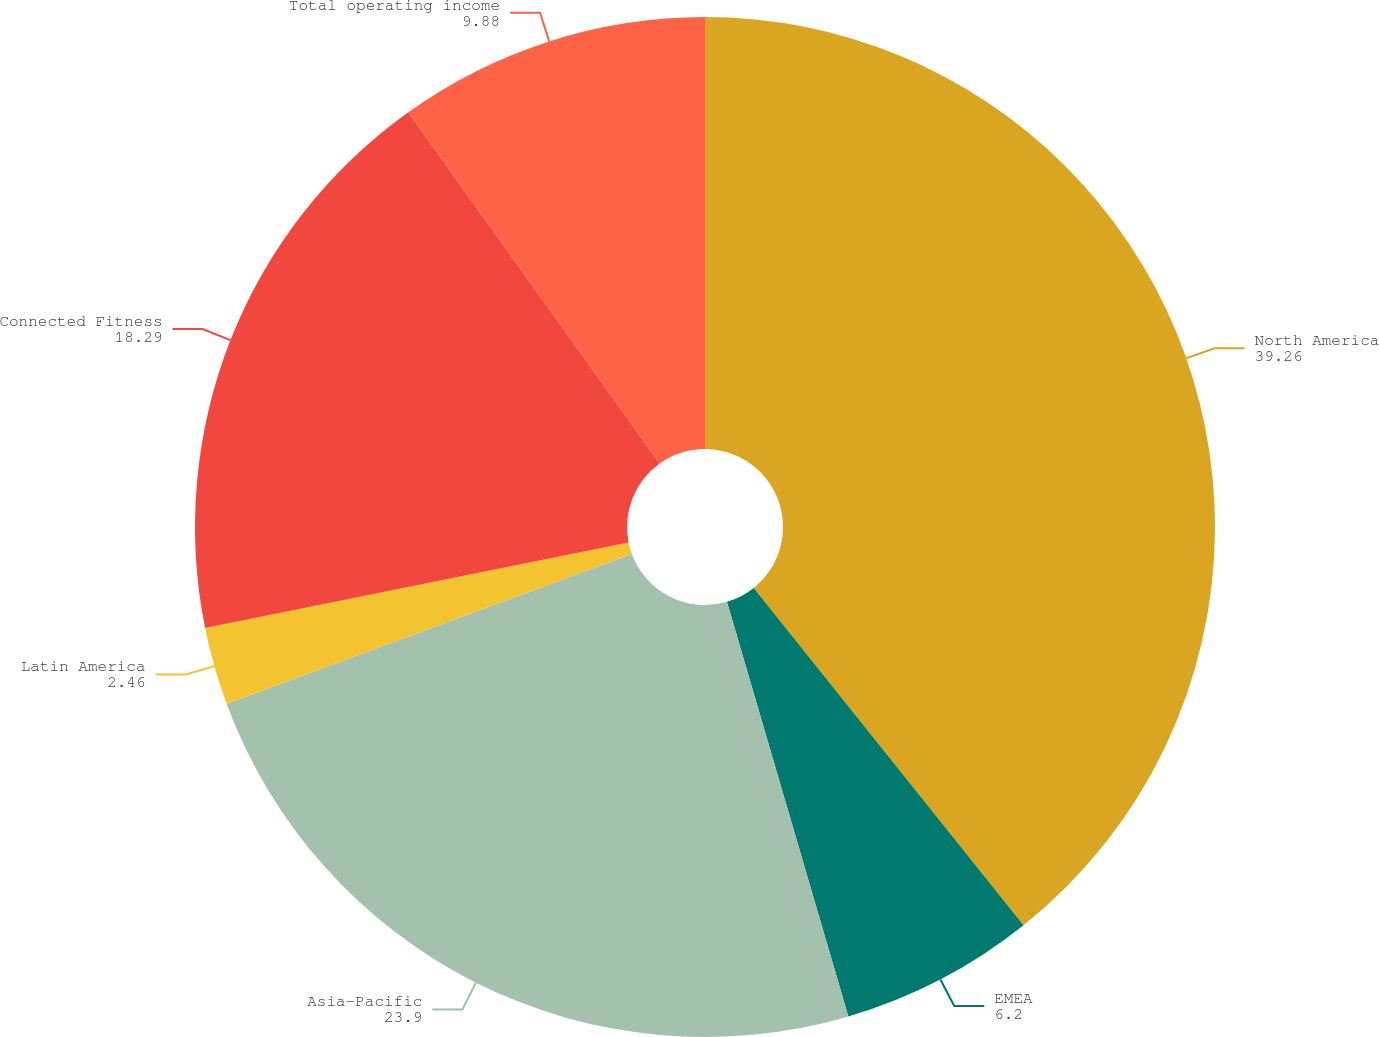Convert chart to OTSL. <chart><loc_0><loc_0><loc_500><loc_500><pie_chart><fcel>North America<fcel>EMEA<fcel>Asia-Pacific<fcel>Latin America<fcel>Connected Fitness<fcel>Total operating income<nl><fcel>39.26%<fcel>6.2%<fcel>23.9%<fcel>2.46%<fcel>18.29%<fcel>9.88%<nl></chart> 